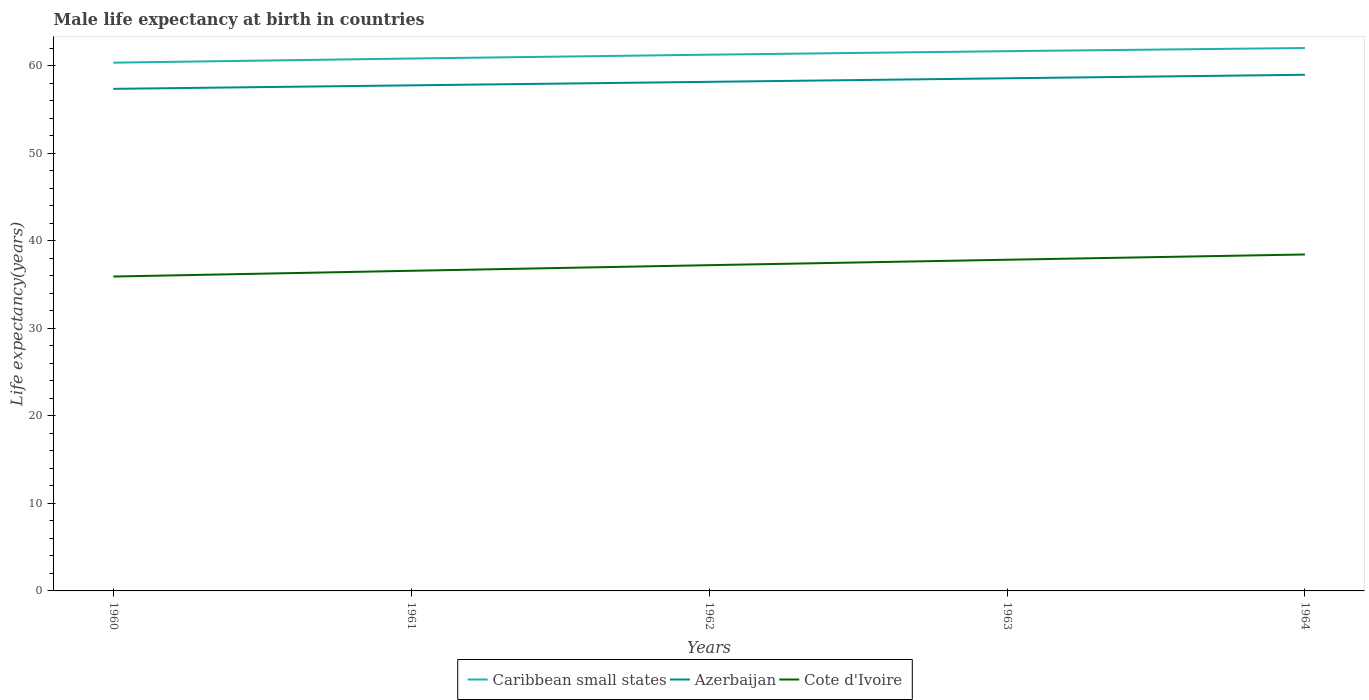How many different coloured lines are there?
Provide a succinct answer. 3. Across all years, what is the maximum male life expectancy at birth in Caribbean small states?
Ensure brevity in your answer.  60.34. In which year was the male life expectancy at birth in Cote d'Ivoire maximum?
Offer a very short reply. 1960. What is the total male life expectancy at birth in Azerbaijan in the graph?
Give a very brief answer. -1.21. What is the difference between the highest and the second highest male life expectancy at birth in Cote d'Ivoire?
Make the answer very short. 2.52. What is the difference between the highest and the lowest male life expectancy at birth in Caribbean small states?
Offer a terse response. 3. Is the male life expectancy at birth in Cote d'Ivoire strictly greater than the male life expectancy at birth in Caribbean small states over the years?
Offer a very short reply. Yes. How many lines are there?
Keep it short and to the point. 3. How many years are there in the graph?
Provide a short and direct response. 5. What is the difference between two consecutive major ticks on the Y-axis?
Your answer should be compact. 10. Does the graph contain any zero values?
Your answer should be very brief. No. Does the graph contain grids?
Your response must be concise. No. Where does the legend appear in the graph?
Your response must be concise. Bottom center. How are the legend labels stacked?
Offer a very short reply. Horizontal. What is the title of the graph?
Your response must be concise. Male life expectancy at birth in countries. Does "Austria" appear as one of the legend labels in the graph?
Provide a succinct answer. No. What is the label or title of the X-axis?
Provide a succinct answer. Years. What is the label or title of the Y-axis?
Provide a short and direct response. Life expectancy(years). What is the Life expectancy(years) in Caribbean small states in 1960?
Make the answer very short. 60.34. What is the Life expectancy(years) of Azerbaijan in 1960?
Give a very brief answer. 57.35. What is the Life expectancy(years) of Cote d'Ivoire in 1960?
Ensure brevity in your answer.  35.91. What is the Life expectancy(years) in Caribbean small states in 1961?
Offer a terse response. 60.81. What is the Life expectancy(years) in Azerbaijan in 1961?
Your answer should be very brief. 57.75. What is the Life expectancy(years) in Cote d'Ivoire in 1961?
Keep it short and to the point. 36.57. What is the Life expectancy(years) of Caribbean small states in 1962?
Provide a short and direct response. 61.25. What is the Life expectancy(years) in Azerbaijan in 1962?
Your response must be concise. 58.15. What is the Life expectancy(years) in Cote d'Ivoire in 1962?
Offer a terse response. 37.21. What is the Life expectancy(years) in Caribbean small states in 1963?
Provide a succinct answer. 61.65. What is the Life expectancy(years) in Azerbaijan in 1963?
Your response must be concise. 58.55. What is the Life expectancy(years) of Cote d'Ivoire in 1963?
Make the answer very short. 37.83. What is the Life expectancy(years) of Caribbean small states in 1964?
Give a very brief answer. 62.01. What is the Life expectancy(years) in Azerbaijan in 1964?
Make the answer very short. 58.95. What is the Life expectancy(years) of Cote d'Ivoire in 1964?
Your answer should be compact. 38.43. Across all years, what is the maximum Life expectancy(years) of Caribbean small states?
Offer a terse response. 62.01. Across all years, what is the maximum Life expectancy(years) of Azerbaijan?
Make the answer very short. 58.95. Across all years, what is the maximum Life expectancy(years) of Cote d'Ivoire?
Keep it short and to the point. 38.43. Across all years, what is the minimum Life expectancy(years) of Caribbean small states?
Your answer should be compact. 60.34. Across all years, what is the minimum Life expectancy(years) in Azerbaijan?
Ensure brevity in your answer.  57.35. Across all years, what is the minimum Life expectancy(years) of Cote d'Ivoire?
Provide a short and direct response. 35.91. What is the total Life expectancy(years) in Caribbean small states in the graph?
Give a very brief answer. 306.06. What is the total Life expectancy(years) in Azerbaijan in the graph?
Keep it short and to the point. 290.75. What is the total Life expectancy(years) of Cote d'Ivoire in the graph?
Offer a terse response. 185.94. What is the difference between the Life expectancy(years) in Caribbean small states in 1960 and that in 1961?
Provide a short and direct response. -0.47. What is the difference between the Life expectancy(years) in Cote d'Ivoire in 1960 and that in 1961?
Provide a succinct answer. -0.66. What is the difference between the Life expectancy(years) in Caribbean small states in 1960 and that in 1962?
Your answer should be very brief. -0.91. What is the difference between the Life expectancy(years) of Azerbaijan in 1960 and that in 1962?
Offer a very short reply. -0.8. What is the difference between the Life expectancy(years) of Cote d'Ivoire in 1960 and that in 1962?
Provide a short and direct response. -1.3. What is the difference between the Life expectancy(years) of Caribbean small states in 1960 and that in 1963?
Your answer should be compact. -1.31. What is the difference between the Life expectancy(years) of Azerbaijan in 1960 and that in 1963?
Give a very brief answer. -1.21. What is the difference between the Life expectancy(years) in Cote d'Ivoire in 1960 and that in 1963?
Offer a very short reply. -1.92. What is the difference between the Life expectancy(years) in Caribbean small states in 1960 and that in 1964?
Provide a short and direct response. -1.67. What is the difference between the Life expectancy(years) of Azerbaijan in 1960 and that in 1964?
Offer a very short reply. -1.61. What is the difference between the Life expectancy(years) of Cote d'Ivoire in 1960 and that in 1964?
Your answer should be compact. -2.52. What is the difference between the Life expectancy(years) in Caribbean small states in 1961 and that in 1962?
Keep it short and to the point. -0.44. What is the difference between the Life expectancy(years) in Azerbaijan in 1961 and that in 1962?
Offer a terse response. -0.4. What is the difference between the Life expectancy(years) of Cote d'Ivoire in 1961 and that in 1962?
Provide a short and direct response. -0.64. What is the difference between the Life expectancy(years) in Caribbean small states in 1961 and that in 1963?
Make the answer very short. -0.84. What is the difference between the Life expectancy(years) in Azerbaijan in 1961 and that in 1963?
Make the answer very short. -0.81. What is the difference between the Life expectancy(years) of Cote d'Ivoire in 1961 and that in 1963?
Your response must be concise. -1.26. What is the difference between the Life expectancy(years) in Caribbean small states in 1961 and that in 1964?
Make the answer very short. -1.2. What is the difference between the Life expectancy(years) of Azerbaijan in 1961 and that in 1964?
Provide a succinct answer. -1.21. What is the difference between the Life expectancy(years) in Cote d'Ivoire in 1961 and that in 1964?
Give a very brief answer. -1.86. What is the difference between the Life expectancy(years) of Caribbean small states in 1962 and that in 1963?
Provide a short and direct response. -0.4. What is the difference between the Life expectancy(years) in Azerbaijan in 1962 and that in 1963?
Provide a succinct answer. -0.4. What is the difference between the Life expectancy(years) of Cote d'Ivoire in 1962 and that in 1963?
Make the answer very short. -0.62. What is the difference between the Life expectancy(years) of Caribbean small states in 1962 and that in 1964?
Keep it short and to the point. -0.76. What is the difference between the Life expectancy(years) of Azerbaijan in 1962 and that in 1964?
Offer a very short reply. -0.81. What is the difference between the Life expectancy(years) of Cote d'Ivoire in 1962 and that in 1964?
Provide a short and direct response. -1.22. What is the difference between the Life expectancy(years) of Caribbean small states in 1963 and that in 1964?
Provide a short and direct response. -0.36. What is the difference between the Life expectancy(years) in Azerbaijan in 1963 and that in 1964?
Your answer should be very brief. -0.4. What is the difference between the Life expectancy(years) of Cote d'Ivoire in 1963 and that in 1964?
Ensure brevity in your answer.  -0.6. What is the difference between the Life expectancy(years) of Caribbean small states in 1960 and the Life expectancy(years) of Azerbaijan in 1961?
Give a very brief answer. 2.59. What is the difference between the Life expectancy(years) of Caribbean small states in 1960 and the Life expectancy(years) of Cote d'Ivoire in 1961?
Ensure brevity in your answer.  23.77. What is the difference between the Life expectancy(years) in Azerbaijan in 1960 and the Life expectancy(years) in Cote d'Ivoire in 1961?
Keep it short and to the point. 20.78. What is the difference between the Life expectancy(years) of Caribbean small states in 1960 and the Life expectancy(years) of Azerbaijan in 1962?
Give a very brief answer. 2.19. What is the difference between the Life expectancy(years) in Caribbean small states in 1960 and the Life expectancy(years) in Cote d'Ivoire in 1962?
Your answer should be very brief. 23.13. What is the difference between the Life expectancy(years) in Azerbaijan in 1960 and the Life expectancy(years) in Cote d'Ivoire in 1962?
Give a very brief answer. 20.14. What is the difference between the Life expectancy(years) of Caribbean small states in 1960 and the Life expectancy(years) of Azerbaijan in 1963?
Make the answer very short. 1.78. What is the difference between the Life expectancy(years) of Caribbean small states in 1960 and the Life expectancy(years) of Cote d'Ivoire in 1963?
Provide a short and direct response. 22.51. What is the difference between the Life expectancy(years) in Azerbaijan in 1960 and the Life expectancy(years) in Cote d'Ivoire in 1963?
Your response must be concise. 19.52. What is the difference between the Life expectancy(years) of Caribbean small states in 1960 and the Life expectancy(years) of Azerbaijan in 1964?
Provide a succinct answer. 1.38. What is the difference between the Life expectancy(years) in Caribbean small states in 1960 and the Life expectancy(years) in Cote d'Ivoire in 1964?
Provide a succinct answer. 21.91. What is the difference between the Life expectancy(years) in Azerbaijan in 1960 and the Life expectancy(years) in Cote d'Ivoire in 1964?
Your answer should be compact. 18.92. What is the difference between the Life expectancy(years) of Caribbean small states in 1961 and the Life expectancy(years) of Azerbaijan in 1962?
Ensure brevity in your answer.  2.66. What is the difference between the Life expectancy(years) in Caribbean small states in 1961 and the Life expectancy(years) in Cote d'Ivoire in 1962?
Provide a short and direct response. 23.6. What is the difference between the Life expectancy(years) of Azerbaijan in 1961 and the Life expectancy(years) of Cote d'Ivoire in 1962?
Make the answer very short. 20.54. What is the difference between the Life expectancy(years) in Caribbean small states in 1961 and the Life expectancy(years) in Azerbaijan in 1963?
Ensure brevity in your answer.  2.26. What is the difference between the Life expectancy(years) of Caribbean small states in 1961 and the Life expectancy(years) of Cote d'Ivoire in 1963?
Offer a terse response. 22.98. What is the difference between the Life expectancy(years) in Azerbaijan in 1961 and the Life expectancy(years) in Cote d'Ivoire in 1963?
Give a very brief answer. 19.92. What is the difference between the Life expectancy(years) of Caribbean small states in 1961 and the Life expectancy(years) of Azerbaijan in 1964?
Make the answer very short. 1.86. What is the difference between the Life expectancy(years) of Caribbean small states in 1961 and the Life expectancy(years) of Cote d'Ivoire in 1964?
Your answer should be very brief. 22.38. What is the difference between the Life expectancy(years) of Azerbaijan in 1961 and the Life expectancy(years) of Cote d'Ivoire in 1964?
Give a very brief answer. 19.32. What is the difference between the Life expectancy(years) of Caribbean small states in 1962 and the Life expectancy(years) of Azerbaijan in 1963?
Provide a succinct answer. 2.7. What is the difference between the Life expectancy(years) of Caribbean small states in 1962 and the Life expectancy(years) of Cote d'Ivoire in 1963?
Make the answer very short. 23.42. What is the difference between the Life expectancy(years) in Azerbaijan in 1962 and the Life expectancy(years) in Cote d'Ivoire in 1963?
Give a very brief answer. 20.32. What is the difference between the Life expectancy(years) of Caribbean small states in 1962 and the Life expectancy(years) of Azerbaijan in 1964?
Ensure brevity in your answer.  2.29. What is the difference between the Life expectancy(years) of Caribbean small states in 1962 and the Life expectancy(years) of Cote d'Ivoire in 1964?
Your answer should be very brief. 22.82. What is the difference between the Life expectancy(years) in Azerbaijan in 1962 and the Life expectancy(years) in Cote d'Ivoire in 1964?
Provide a short and direct response. 19.72. What is the difference between the Life expectancy(years) in Caribbean small states in 1963 and the Life expectancy(years) in Azerbaijan in 1964?
Provide a short and direct response. 2.69. What is the difference between the Life expectancy(years) in Caribbean small states in 1963 and the Life expectancy(years) in Cote d'Ivoire in 1964?
Offer a terse response. 23.22. What is the difference between the Life expectancy(years) of Azerbaijan in 1963 and the Life expectancy(years) of Cote d'Ivoire in 1964?
Ensure brevity in your answer.  20.12. What is the average Life expectancy(years) of Caribbean small states per year?
Provide a succinct answer. 61.21. What is the average Life expectancy(years) of Azerbaijan per year?
Your response must be concise. 58.15. What is the average Life expectancy(years) in Cote d'Ivoire per year?
Make the answer very short. 37.19. In the year 1960, what is the difference between the Life expectancy(years) in Caribbean small states and Life expectancy(years) in Azerbaijan?
Your response must be concise. 2.99. In the year 1960, what is the difference between the Life expectancy(years) in Caribbean small states and Life expectancy(years) in Cote d'Ivoire?
Provide a succinct answer. 24.43. In the year 1960, what is the difference between the Life expectancy(years) of Azerbaijan and Life expectancy(years) of Cote d'Ivoire?
Your answer should be very brief. 21.44. In the year 1961, what is the difference between the Life expectancy(years) in Caribbean small states and Life expectancy(years) in Azerbaijan?
Your answer should be compact. 3.06. In the year 1961, what is the difference between the Life expectancy(years) in Caribbean small states and Life expectancy(years) in Cote d'Ivoire?
Offer a very short reply. 24.24. In the year 1961, what is the difference between the Life expectancy(years) of Azerbaijan and Life expectancy(years) of Cote d'Ivoire?
Your response must be concise. 21.18. In the year 1962, what is the difference between the Life expectancy(years) of Caribbean small states and Life expectancy(years) of Azerbaijan?
Provide a succinct answer. 3.1. In the year 1962, what is the difference between the Life expectancy(years) of Caribbean small states and Life expectancy(years) of Cote d'Ivoire?
Give a very brief answer. 24.04. In the year 1962, what is the difference between the Life expectancy(years) in Azerbaijan and Life expectancy(years) in Cote d'Ivoire?
Your answer should be compact. 20.94. In the year 1963, what is the difference between the Life expectancy(years) in Caribbean small states and Life expectancy(years) in Azerbaijan?
Your response must be concise. 3.1. In the year 1963, what is the difference between the Life expectancy(years) in Caribbean small states and Life expectancy(years) in Cote d'Ivoire?
Provide a succinct answer. 23.82. In the year 1963, what is the difference between the Life expectancy(years) of Azerbaijan and Life expectancy(years) of Cote d'Ivoire?
Keep it short and to the point. 20.73. In the year 1964, what is the difference between the Life expectancy(years) in Caribbean small states and Life expectancy(years) in Azerbaijan?
Provide a short and direct response. 3.06. In the year 1964, what is the difference between the Life expectancy(years) in Caribbean small states and Life expectancy(years) in Cote d'Ivoire?
Offer a very short reply. 23.58. In the year 1964, what is the difference between the Life expectancy(years) of Azerbaijan and Life expectancy(years) of Cote d'Ivoire?
Provide a succinct answer. 20.52. What is the ratio of the Life expectancy(years) in Azerbaijan in 1960 to that in 1961?
Give a very brief answer. 0.99. What is the ratio of the Life expectancy(years) of Caribbean small states in 1960 to that in 1962?
Provide a succinct answer. 0.99. What is the ratio of the Life expectancy(years) in Azerbaijan in 1960 to that in 1962?
Give a very brief answer. 0.99. What is the ratio of the Life expectancy(years) of Cote d'Ivoire in 1960 to that in 1962?
Give a very brief answer. 0.97. What is the ratio of the Life expectancy(years) of Caribbean small states in 1960 to that in 1963?
Your response must be concise. 0.98. What is the ratio of the Life expectancy(years) in Azerbaijan in 1960 to that in 1963?
Keep it short and to the point. 0.98. What is the ratio of the Life expectancy(years) in Cote d'Ivoire in 1960 to that in 1963?
Offer a very short reply. 0.95. What is the ratio of the Life expectancy(years) in Azerbaijan in 1960 to that in 1964?
Make the answer very short. 0.97. What is the ratio of the Life expectancy(years) in Cote d'Ivoire in 1960 to that in 1964?
Give a very brief answer. 0.93. What is the ratio of the Life expectancy(years) of Cote d'Ivoire in 1961 to that in 1962?
Keep it short and to the point. 0.98. What is the ratio of the Life expectancy(years) of Caribbean small states in 1961 to that in 1963?
Provide a succinct answer. 0.99. What is the ratio of the Life expectancy(years) of Azerbaijan in 1961 to that in 1963?
Your response must be concise. 0.99. What is the ratio of the Life expectancy(years) of Cote d'Ivoire in 1961 to that in 1963?
Keep it short and to the point. 0.97. What is the ratio of the Life expectancy(years) of Caribbean small states in 1961 to that in 1964?
Offer a terse response. 0.98. What is the ratio of the Life expectancy(years) in Azerbaijan in 1961 to that in 1964?
Your answer should be very brief. 0.98. What is the ratio of the Life expectancy(years) in Cote d'Ivoire in 1961 to that in 1964?
Provide a short and direct response. 0.95. What is the ratio of the Life expectancy(years) in Caribbean small states in 1962 to that in 1963?
Offer a terse response. 0.99. What is the ratio of the Life expectancy(years) in Cote d'Ivoire in 1962 to that in 1963?
Offer a terse response. 0.98. What is the ratio of the Life expectancy(years) in Caribbean small states in 1962 to that in 1964?
Keep it short and to the point. 0.99. What is the ratio of the Life expectancy(years) of Azerbaijan in 1962 to that in 1964?
Make the answer very short. 0.99. What is the ratio of the Life expectancy(years) in Cote d'Ivoire in 1962 to that in 1964?
Provide a succinct answer. 0.97. What is the ratio of the Life expectancy(years) in Cote d'Ivoire in 1963 to that in 1964?
Keep it short and to the point. 0.98. What is the difference between the highest and the second highest Life expectancy(years) in Caribbean small states?
Your answer should be compact. 0.36. What is the difference between the highest and the second highest Life expectancy(years) of Azerbaijan?
Make the answer very short. 0.4. What is the difference between the highest and the second highest Life expectancy(years) in Cote d'Ivoire?
Provide a succinct answer. 0.6. What is the difference between the highest and the lowest Life expectancy(years) of Caribbean small states?
Give a very brief answer. 1.67. What is the difference between the highest and the lowest Life expectancy(years) of Azerbaijan?
Keep it short and to the point. 1.61. What is the difference between the highest and the lowest Life expectancy(years) of Cote d'Ivoire?
Your answer should be very brief. 2.52. 